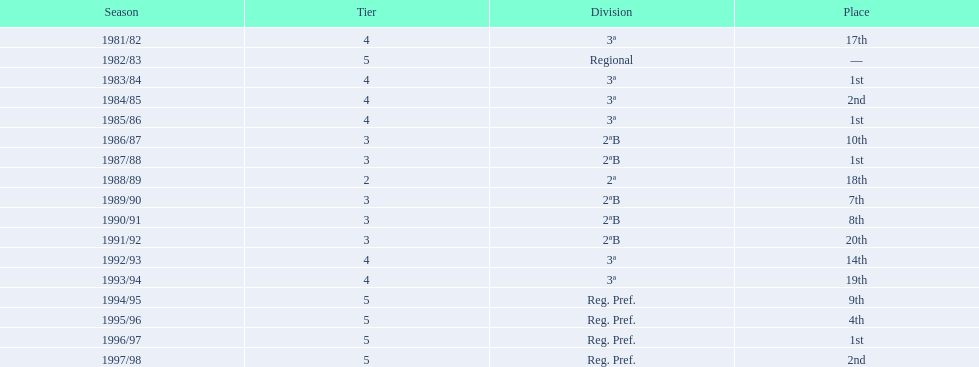What is the lowest place the team has come out? 20th. In what year did they come out in 20th place? 1991/92. 